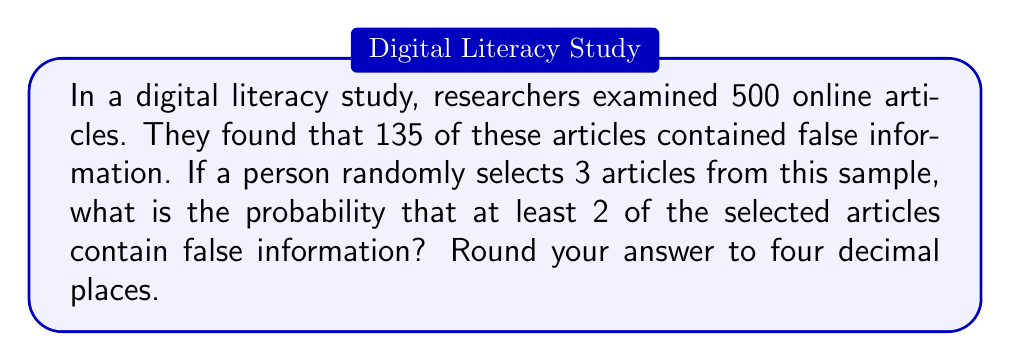Show me your answer to this math problem. Let's approach this step-by-step:

1) First, we need to calculate the probability of selecting an article with false information:
   $p = \frac{135}{500} = 0.27$

2) The probability of selecting an article without false information is:
   $q = 1 - p = 1 - 0.27 = 0.73$

3) We're looking for the probability of at least 2 out of 3 articles containing false information. This can happen in two ways:
   - Exactly 2 out of 3 articles contain false information
   - All 3 articles contain false information

4) Let's calculate these probabilities using the binomial probability formula:
   $P(X = k) = \binom{n}{k} p^k q^{n-k}$

   Where $n$ is the number of trials, $k$ is the number of successes, $p$ is the probability of success, and $q$ is the probability of failure.

5) Probability of exactly 2 out of 3 articles containing false information:
   $P(X = 2) = \binom{3}{2} (0.27)^2 (0.73)^1 = 3 \cdot 0.0729 \cdot 0.73 = 0.1596$

6) Probability of all 3 articles containing false information:
   $P(X = 3) = \binom{3}{3} (0.27)^3 (0.73)^0 = 1 \cdot 0.0197 \cdot 1 = 0.0197$

7) The probability of at least 2 articles containing false information is the sum of these probabilities:
   $P(X \geq 2) = P(X = 2) + P(X = 3) = 0.1596 + 0.0197 = 0.1793$

8) Rounding to four decimal places: 0.1793
Answer: 0.1793 